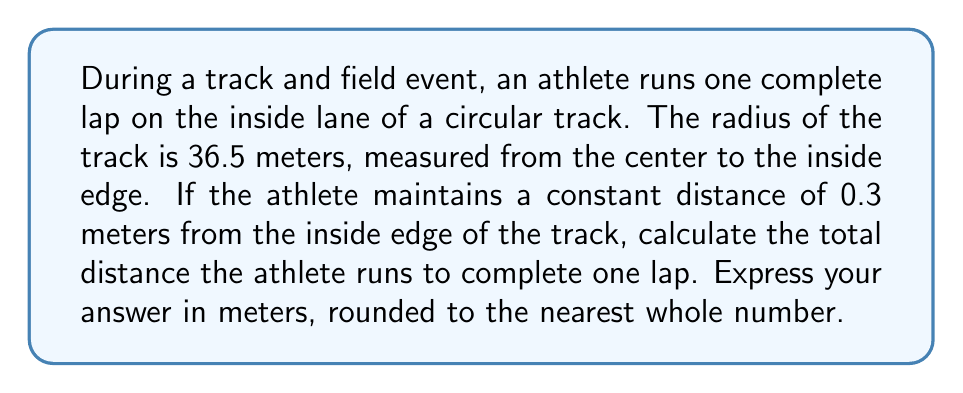Can you answer this question? To solve this problem, we'll use concepts from polar coordinates and circular motion. Let's break it down step-by-step:

1) The athlete runs on a circular path. The distance traveled on a circular path is given by the arc length formula:

   $$s = r\theta$$

   where $s$ is the arc length, $r$ is the radius, and $\theta$ is the angle in radians.

2) For one complete lap, the athlete travels a full circle, which is $2\pi$ radians.

3) The radius of the athlete's path is not exactly the same as the track's radius. We need to add the distance the athlete stays from the edge:

   $$r = 36.5 \text{ m} + 0.3 \text{ m} = 36.8 \text{ m}$$

4) Now we can substitute these values into the arc length formula:

   $$s = r\theta = 36.8 \text{ m} \times 2\pi$$

5) Calculate:
   
   $$s = 36.8 \text{ m} \times 2 \times 3.14159... = 231.12... \text{ m}$$

6) Rounding to the nearest whole number:

   $$s \approx 231 \text{ m}$$

Therefore, the athlete runs approximately 231 meters to complete one lap.
Answer: 231 meters 